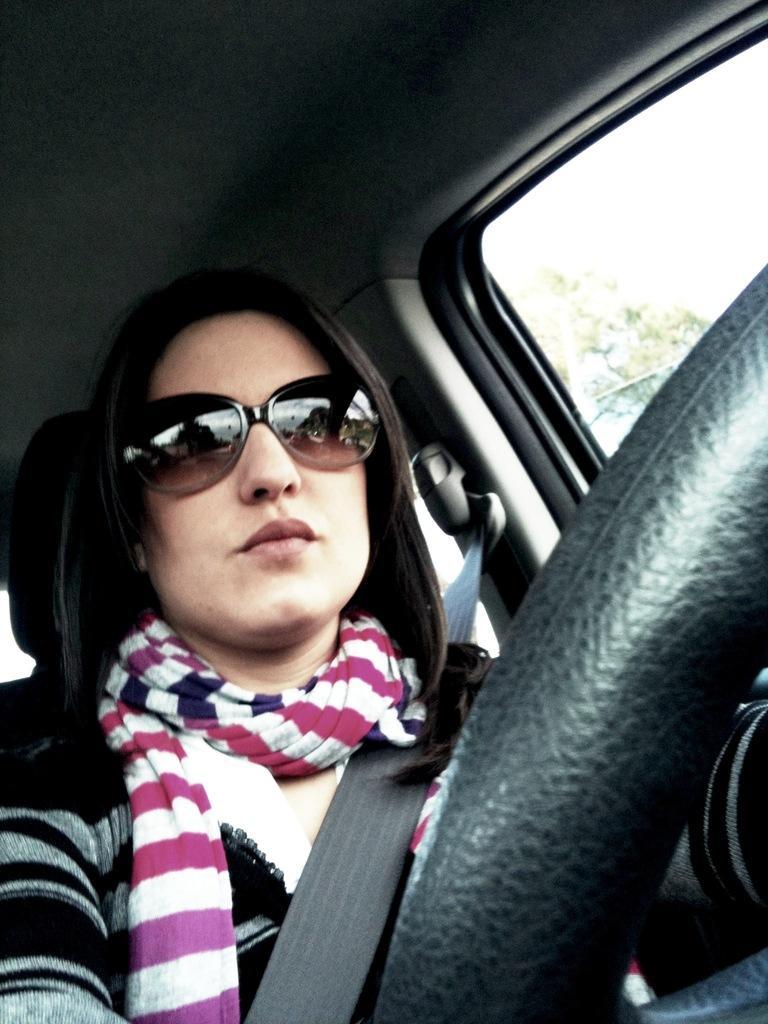Can you describe this image briefly? In this picture I can see a woman with a scarf and glasses, is sitting inside a vehicle, and in the background there is a tree. 